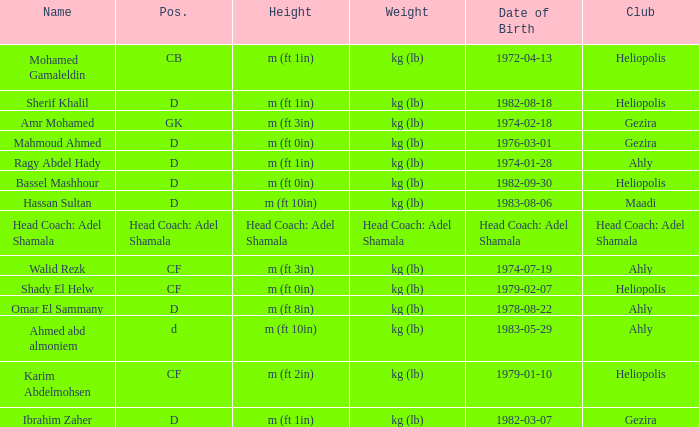What is Pos., when Height is "m (ft 10in)", and when Date of Birth is "1983-05-29"? D. Could you help me parse every detail presented in this table? {'header': ['Name', 'Pos.', 'Height', 'Weight', 'Date of Birth', 'Club'], 'rows': [['Mohamed Gamaleldin', 'CB', 'm (ft 1in)', 'kg (lb)', '1972-04-13', 'Heliopolis'], ['Sherif Khalil', 'D', 'm (ft 1in)', 'kg (lb)', '1982-08-18', 'Heliopolis'], ['Amr Mohamed', 'GK', 'm (ft 3in)', 'kg (lb)', '1974-02-18', 'Gezira'], ['Mahmoud Ahmed', 'D', 'm (ft 0in)', 'kg (lb)', '1976-03-01', 'Gezira'], ['Ragy Abdel Hady', 'D', 'm (ft 1in)', 'kg (lb)', '1974-01-28', 'Ahly'], ['Bassel Mashhour', 'D', 'm (ft 0in)', 'kg (lb)', '1982-09-30', 'Heliopolis'], ['Hassan Sultan', 'D', 'm (ft 10in)', 'kg (lb)', '1983-08-06', 'Maadi'], ['Head Coach: Adel Shamala', 'Head Coach: Adel Shamala', 'Head Coach: Adel Shamala', 'Head Coach: Adel Shamala', 'Head Coach: Adel Shamala', 'Head Coach: Adel Shamala'], ['Walid Rezk', 'CF', 'm (ft 3in)', 'kg (lb)', '1974-07-19', 'Ahly'], ['Shady El Helw', 'CF', 'm (ft 0in)', 'kg (lb)', '1979-02-07', 'Heliopolis'], ['Omar El Sammany', 'D', 'm (ft 8in)', 'kg (lb)', '1978-08-22', 'Ahly'], ['Ahmed abd almoniem', 'd', 'm (ft 10in)', 'kg (lb)', '1983-05-29', 'Ahly'], ['Karim Abdelmohsen', 'CF', 'm (ft 2in)', 'kg (lb)', '1979-01-10', 'Heliopolis'], ['Ibrahim Zaher', 'D', 'm (ft 1in)', 'kg (lb)', '1982-03-07', 'Gezira']]} 